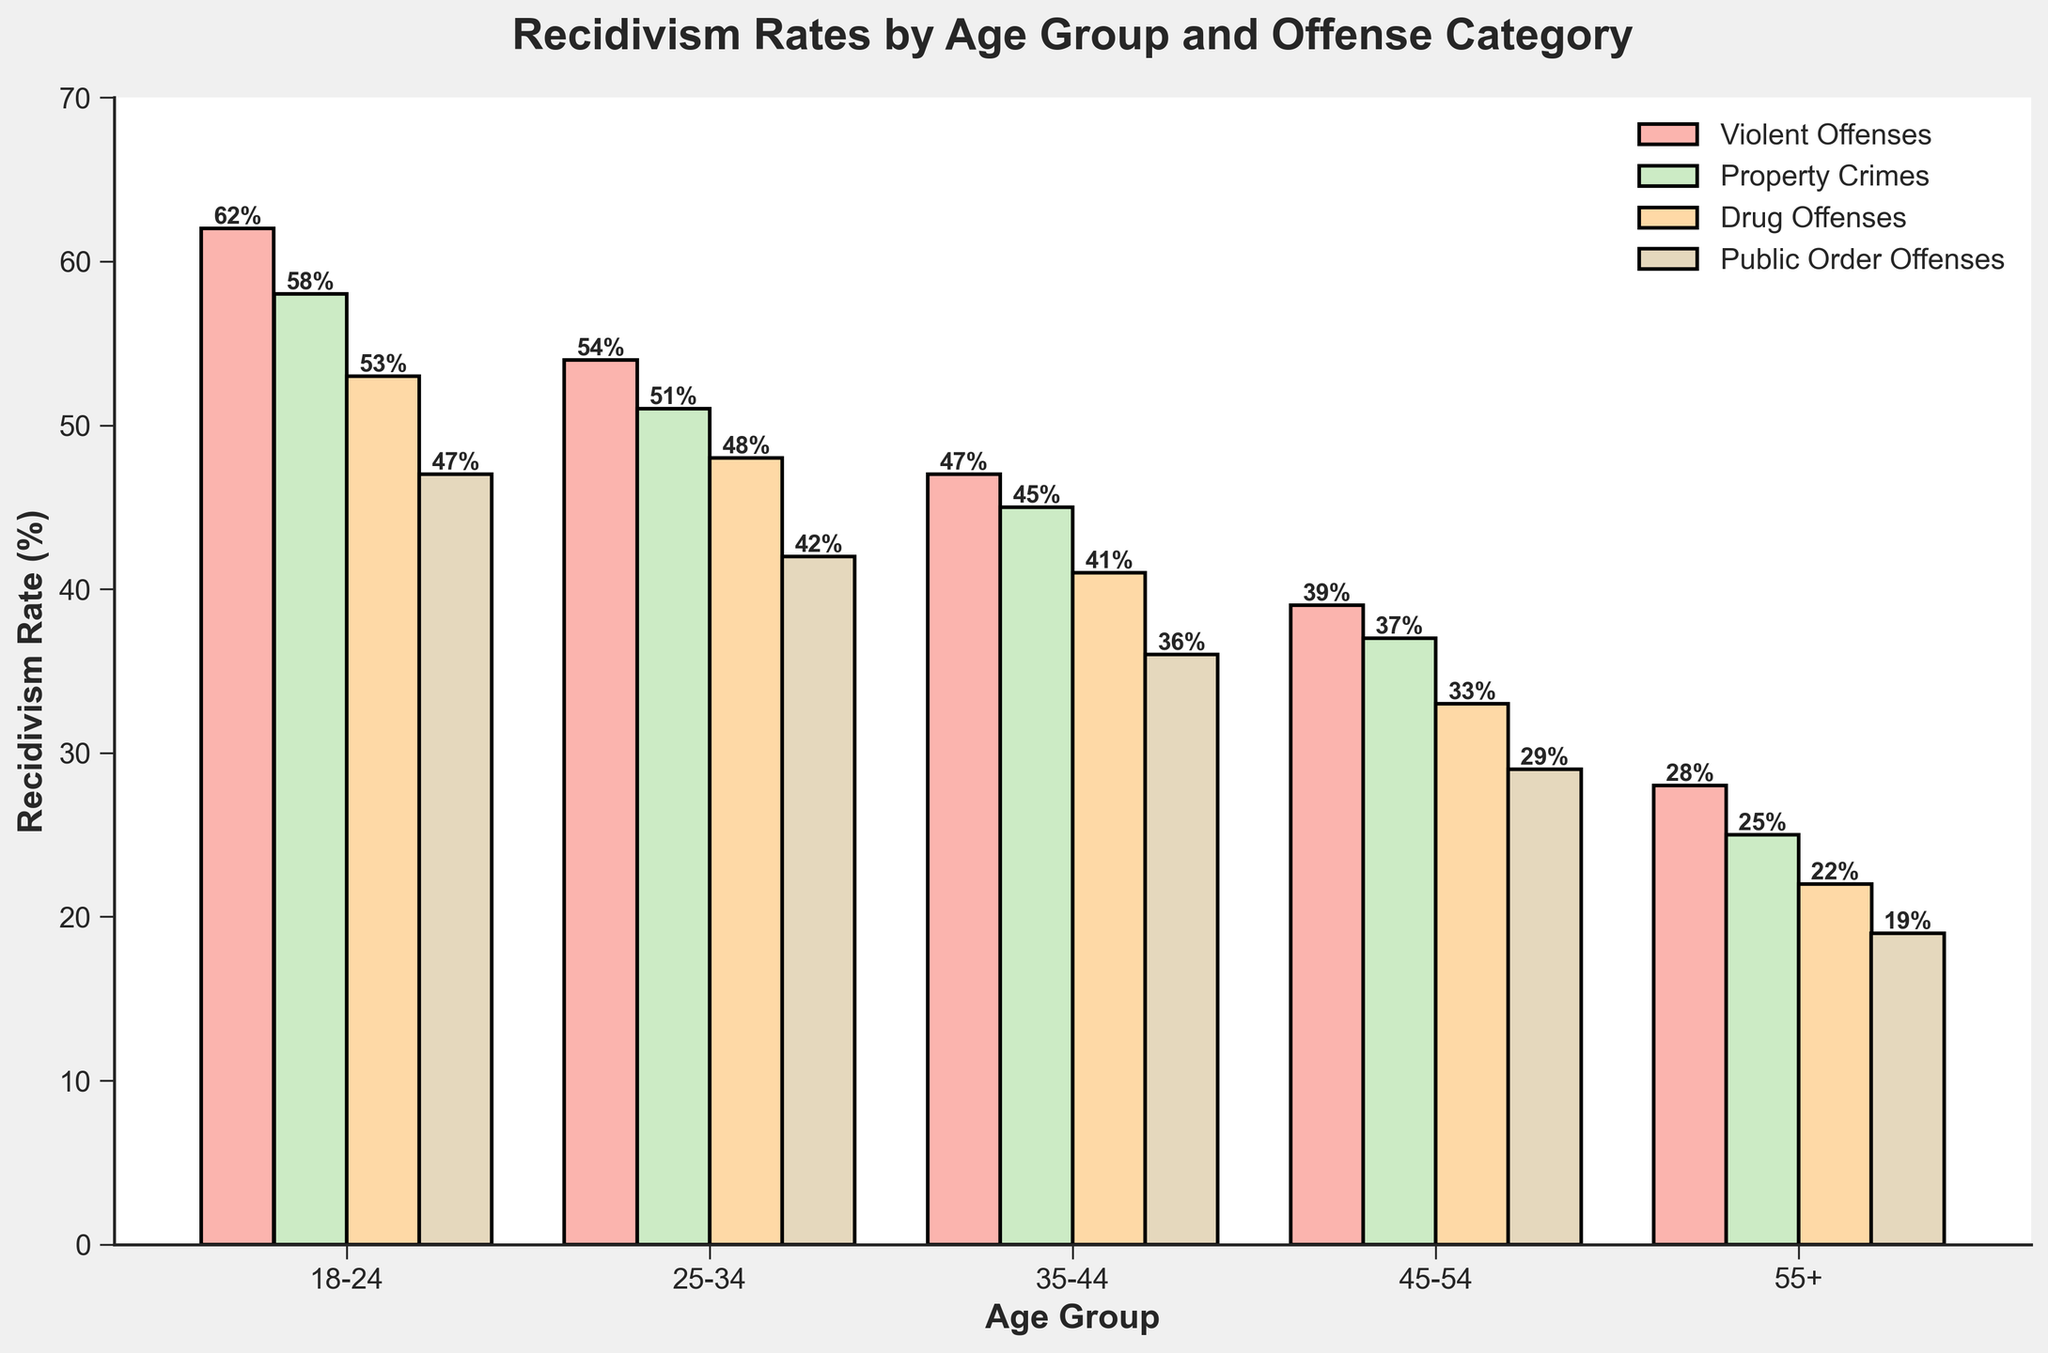What is the recidivism rate of violent offenses for the 18-24 age group? Look at the bar representing violent offenses for the 18-24 age group. The possible values are shown along the y-axis, read the value next to the top of the bar.
Answer: 62% Which age group has the lowest recidivism rate for drug offenses? Find the bars representing drug offenses for all age groups and compare their heights to see which is the shortest.
Answer: 55+ What is the difference in recidivism rates for public order offenses between the 25-34 and 45-54 age groups? Look at the heights of the bars representing public order offenses for the 25-34 and 45-54 age groups. Subtract the value for the 45-54 group from the value for the 25-34 group.
Answer: 42% - 29% = 13% Which offense category has the highest recidivism rate for the 35-44 age group? Compare the heights of the four bars representing the 35-44 age group to determine which is the tallest.
Answer: Violent Offenses What is the average recidivism rate for property crimes across all age groups? Add the recidivism rates for property crimes for all age groups and divide by the number of age groups. Calculation: (58 + 51 + 45 + 37 + 25)/5 = 43.2%
Answer: 43.2% How does the recidivism rate for violent offenses in the 25-34 age group compare to property crimes in the same age group? Compare the heights of the bars representing violent offenses and property crimes in the 25-34 age group.
Answer: Violent Offenses are higher; 54% vs 51% Which age group shows the greatest drop in recidivism rates for drug offenses compared to the previous age group? Calculate the difference in recidivism rates for drug offenses between consecutive age groups and determine which difference is the largest. Calculation: (53-48)=5, (48-41)=7, (41-33)=8, (33-22)=11. The largest drop is between 45-54 and 55+ age groups.
Answer: 55+ What are the visual attributes of the bars representing public order offenses? Mention the position and appearance of the bars representing public order offenses. They are the fourth set of bars from the left in each group and are colored in the final pastel shade.
Answer: Fourth set of bars, pastel shade What can you infer about the trend in recidivism rates across all offense categories as age increases? Observe the general pattern of bar heights from left (younger age groups) to right (older age groups) for each offense category. Notice that the bars tend to decrease in height.
Answer: Recidivism rates decrease with age across all categories 